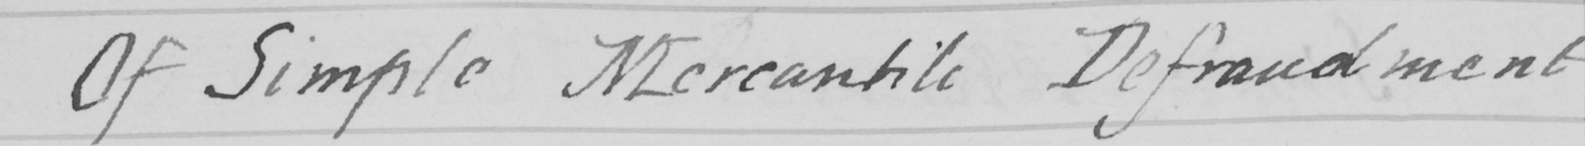What does this handwritten line say? Of Simple Merchantile Defraudment 